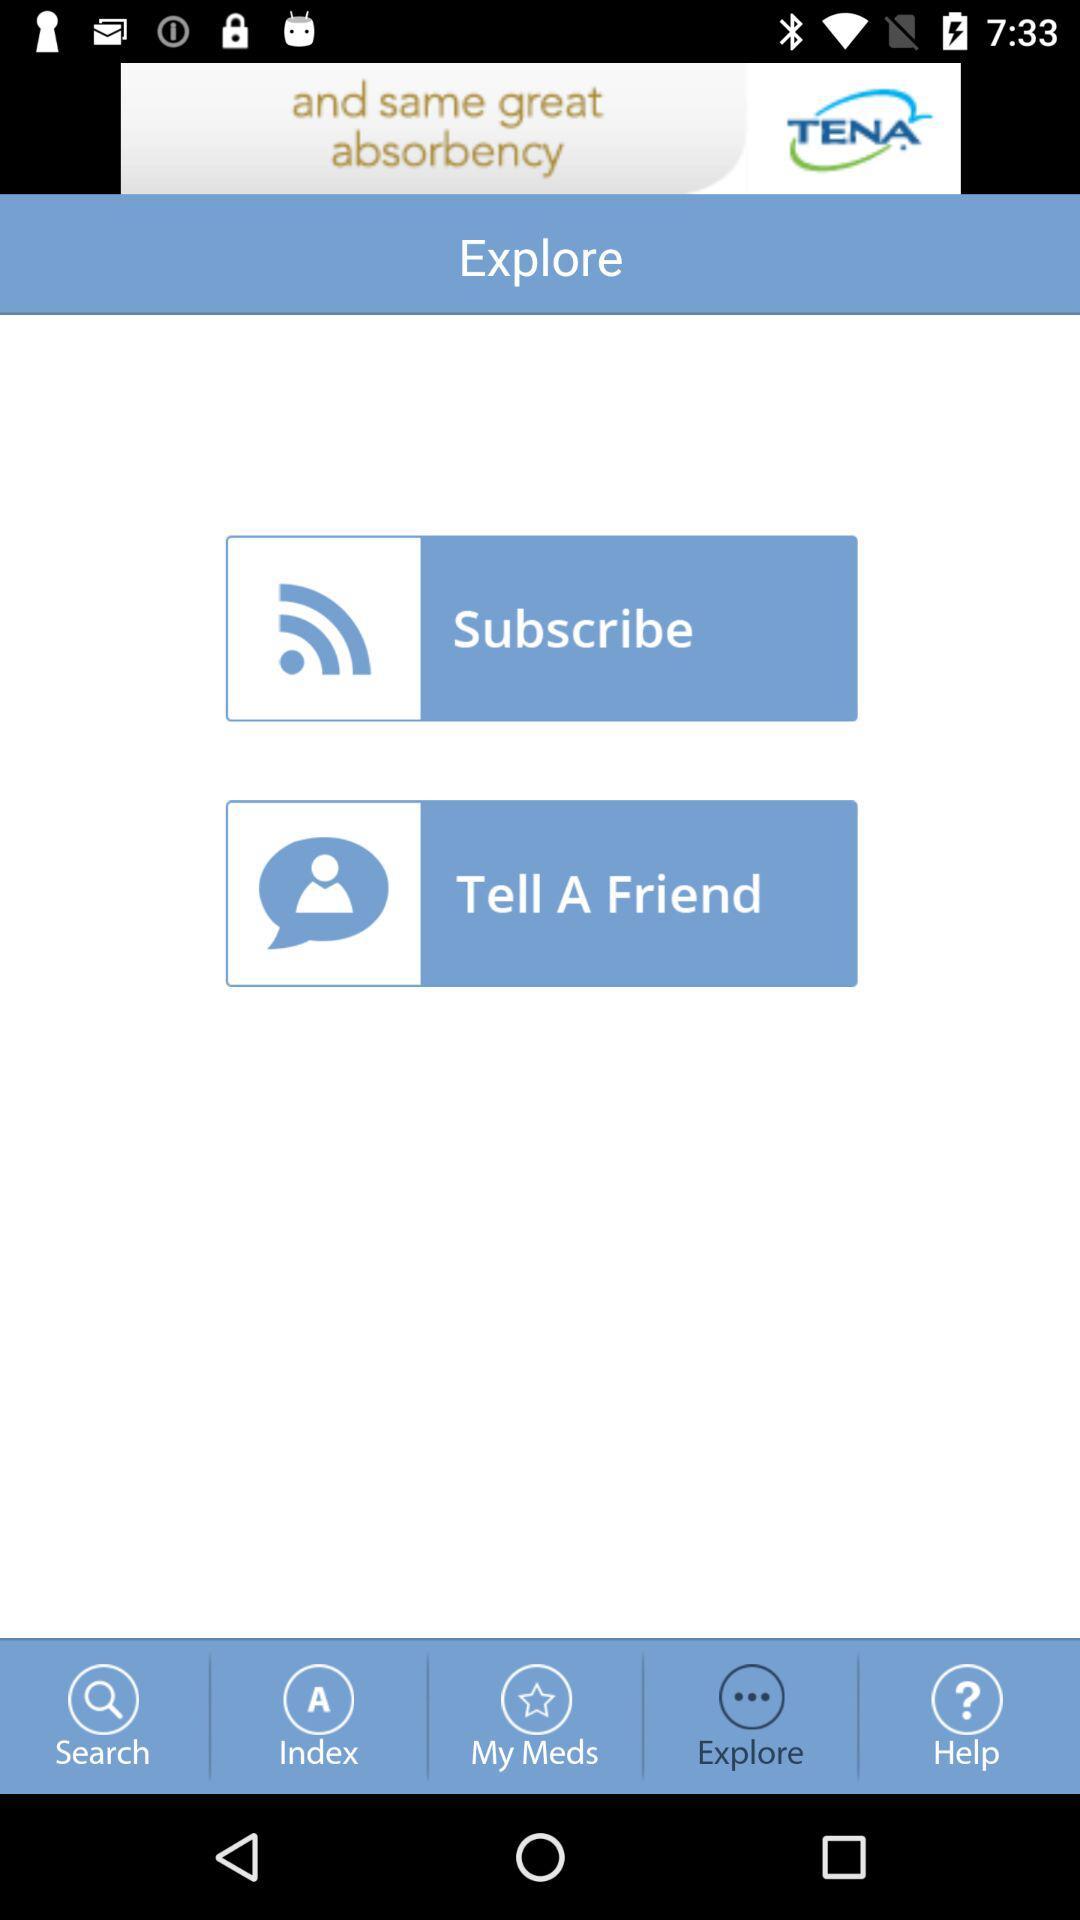What options could we explore? The options you could explore are "Subscribe" and "Tell A Friend". 